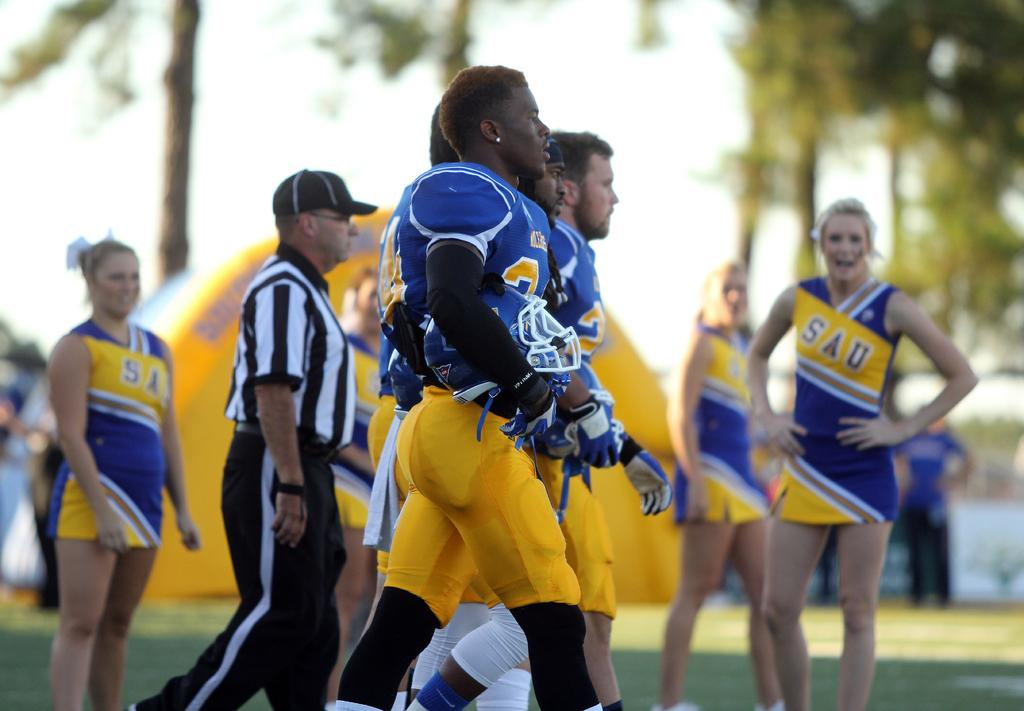<image>
Provide a brief description of the given image. Side view of a football team walking to the field playing for team SAU. 